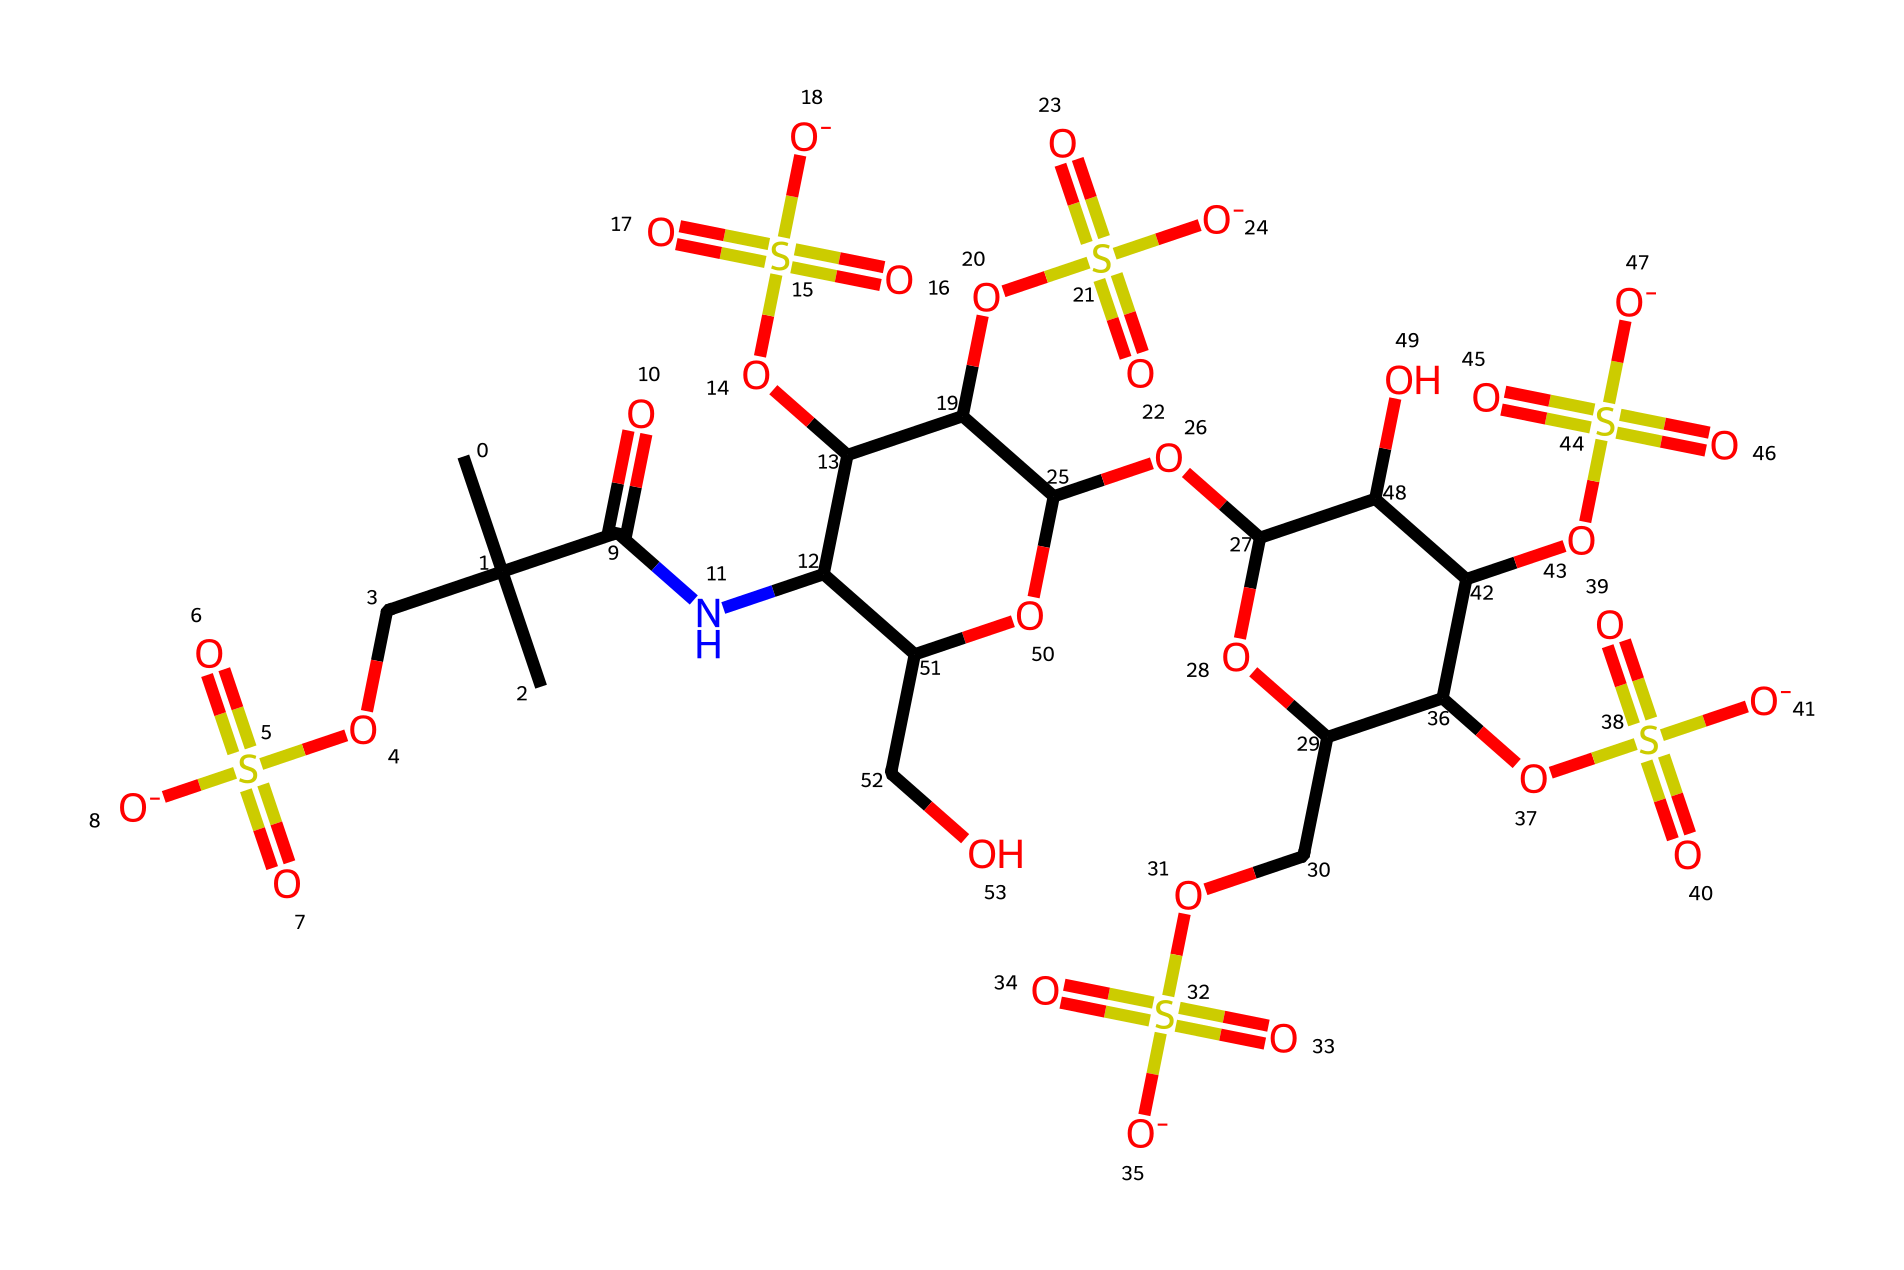What is the molecular formula of this chemical? To find the molecular formula, count the number of each type of atom in the SMILES representation. For this particular structure, you identify the atoms components: carbon (C), oxygen (O), nitrogen (N), and hydrogen (H). After analyzing, you determine the counts for each, leading to the molecular formula: C18H26N2O11S4.
Answer: C18H26N2O11S4 How many sulfur atoms are present in this chemical? The SMILES representation includes “S” to denote sulfur atoms. By scanning through the structure for the “S” symbol, you can count a total of four occurrences. Hence, this chemical has four sulfur atoms.
Answer: 4 What type of functional groups are present in this chemical? To identify functional groups, look for characteristic atoms/groups in the structure. This SMILES features sulfonic acid groups indicated by “S(=O)(=O)[O-]” and an amide group from “C(=O)N”. From this inspection, the functional groups include sulfonic acids and amides.
Answer: sulfonic acids, amides Does this chemical structure have a ring system? Examine the structure for any closed loops or cycles. The presence of “C1” and “C2” in the SMILES indicates that there are ring structures involved. Specifically, you can identify that there are indeed cyclic components in the chemical.
Answer: yes What is the significance of the sulfonic acid groups in this drug? Sulfonic acid groups, denoted as “S(=O)(=O)[O-]”, are typically known to enhance the solubility of the drug in aqueous solutions. This property is crucial for medications as it influences absorption and distribution in the body, particularly in preventing blood clots post-surgery. Thus, their presence significantly supports the drug's pharmacological properties.
Answer: solubility How does the presence of nitrogen affect the behavior of this chemical? The nitrogen atom, as seen in the “NC” part of the structure, contributes to the pharmacological activity by forming amide bonds, which can influence the interaction with biological targets in the body. Nitrogen affects drug properties such as solubility, stability, and potential reactivity with biological systems, critical for its functions in blood clot prevention.
Answer: pharmacological activity 